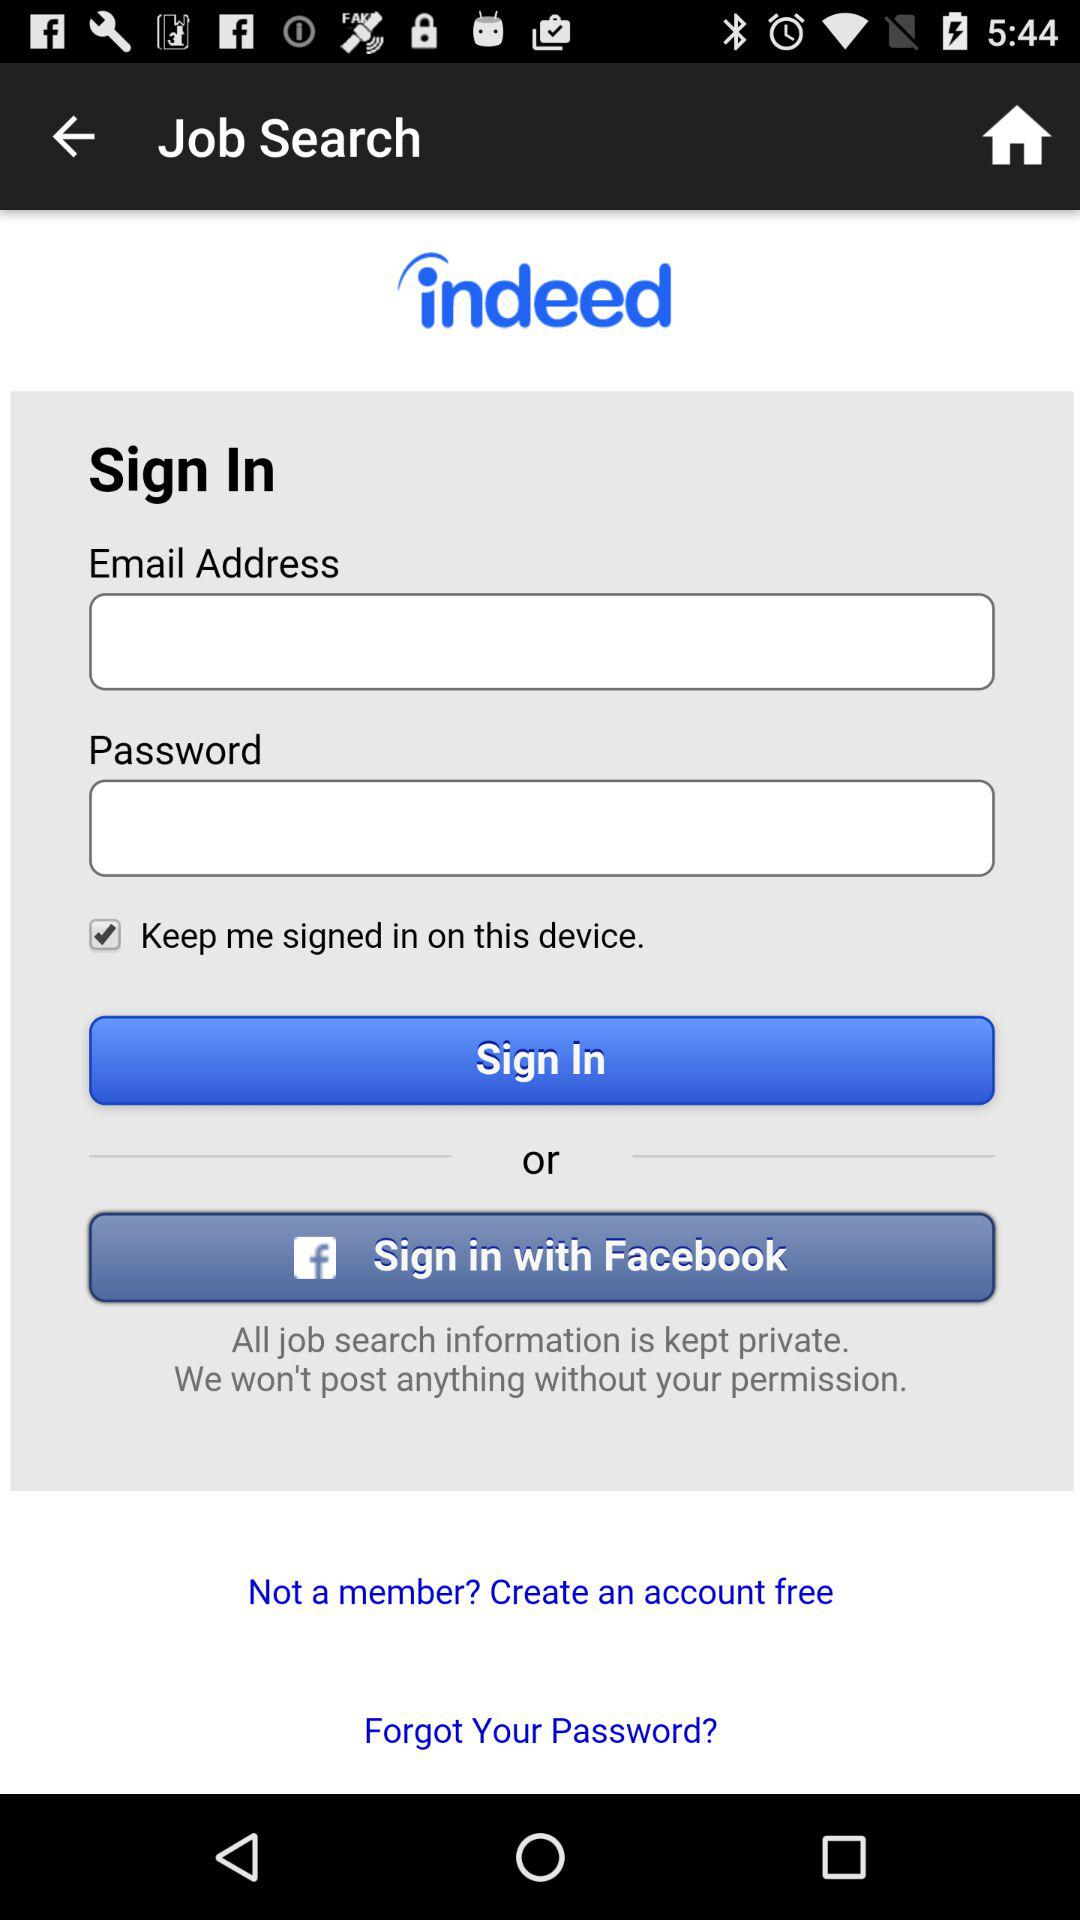What are the options through which I can sign in? You can sign in through "Email" and "Facebook". 